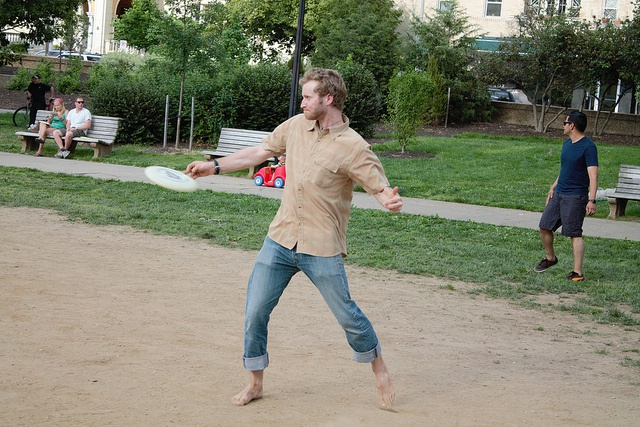Describe the objects in this image and their specific colors. I can see people in darkgreen, tan, darkgray, and gray tones, people in darkgreen, black, navy, and gray tones, bench in darkgreen, black, darkgray, gray, and lightgray tones, bench in darkgreen, darkgray, gray, and black tones, and bench in darkgreen, lightgray, darkgray, black, and gray tones in this image. 